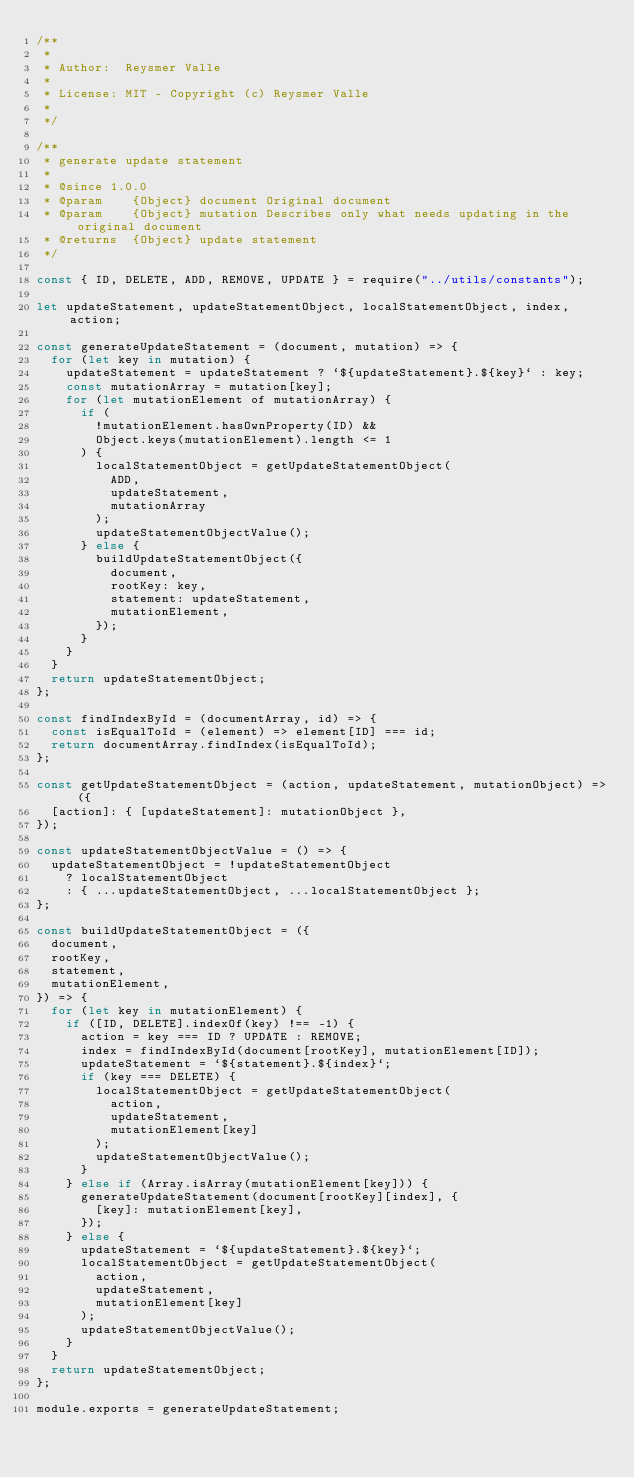<code> <loc_0><loc_0><loc_500><loc_500><_JavaScript_>/**
 *
 * Author:  Reysmer Valle
 *
 * License: MIT - Copyright (c) Reysmer Valle
 *
 */

/**
 * generate update statement
 *
 * @since 1.0.0
 * @param    {Object} document Original document
 * @param    {Object} mutation Describes only what needs updating in the original document
 * @returns  {Object} update statement
 */

const { ID, DELETE, ADD, REMOVE, UPDATE } = require("../utils/constants");

let updateStatement, updateStatementObject, localStatementObject, index, action;

const generateUpdateStatement = (document, mutation) => {
  for (let key in mutation) {
    updateStatement = updateStatement ? `${updateStatement}.${key}` : key;
    const mutationArray = mutation[key];
    for (let mutationElement of mutationArray) {
      if (
        !mutationElement.hasOwnProperty(ID) &&
        Object.keys(mutationElement).length <= 1
      ) {
        localStatementObject = getUpdateStatementObject(
          ADD,
          updateStatement,
          mutationArray
        );
        updateStatementObjectValue();
      } else {
        buildUpdateStatementObject({
          document,
          rootKey: key,
          statement: updateStatement,
          mutationElement,
        });
      }
    }
  }
  return updateStatementObject;
};

const findIndexById = (documentArray, id) => {
  const isEqualToId = (element) => element[ID] === id;
  return documentArray.findIndex(isEqualToId);
};

const getUpdateStatementObject = (action, updateStatement, mutationObject) => ({
  [action]: { [updateStatement]: mutationObject },
});

const updateStatementObjectValue = () => {
  updateStatementObject = !updateStatementObject
    ? localStatementObject
    : { ...updateStatementObject, ...localStatementObject };
};

const buildUpdateStatementObject = ({
  document,
  rootKey,
  statement,
  mutationElement,
}) => {
  for (let key in mutationElement) {
    if ([ID, DELETE].indexOf(key) !== -1) {
      action = key === ID ? UPDATE : REMOVE;
      index = findIndexById(document[rootKey], mutationElement[ID]);
      updateStatement = `${statement}.${index}`;
      if (key === DELETE) {
        localStatementObject = getUpdateStatementObject(
          action,
          updateStatement,
          mutationElement[key]
        );
        updateStatementObjectValue();
      }
    } else if (Array.isArray(mutationElement[key])) {
      generateUpdateStatement(document[rootKey][index], {
        [key]: mutationElement[key],
      });
    } else {
      updateStatement = `${updateStatement}.${key}`;
      localStatementObject = getUpdateStatementObject(
        action,
        updateStatement,
        mutationElement[key]
      );
      updateStatementObjectValue();
    }
  }
  return updateStatementObject;
};

module.exports = generateUpdateStatement;
</code> 